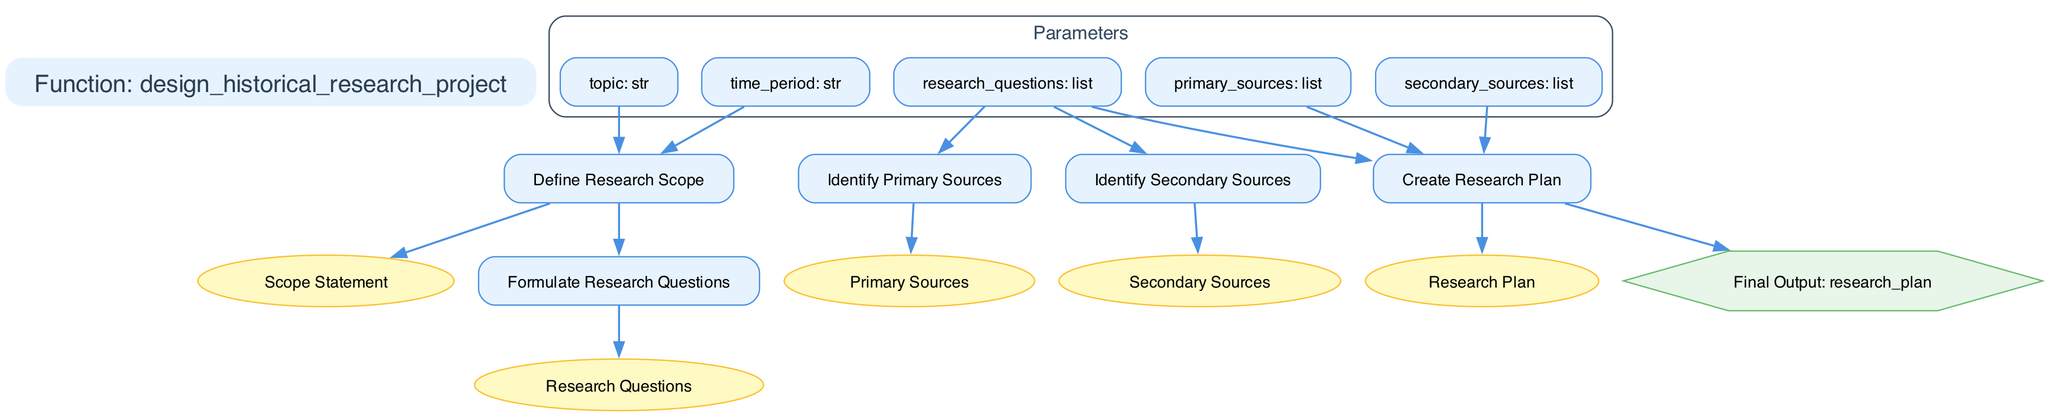What is the name of the function in this diagram? The name of the function is located at the top of the diagram under the title node, which states "Function: design_historical_research_project."
Answer: design_historical_research_project How many steps are in the research design process? By counting the number of nodes that represent the steps of the process, we find there are five steps listed in the diagram: define research scope, formulate research questions, identify primary sources, identify secondary sources, and create research plan.
Answer: 5 What is the output of the last step in the function? The outputs of the last step 'create_research_plan' are detailed in the output node of the diagram, indicating that the final output is the 'research_plan.'
Answer: research_plan Which step has the input "research_questions"? The step "identify_primary_sources" and "identify_secondary_sources" both take "research_questions" as an input, connected by edges leading to these steps in the diagram.
Answer: identify_primary_sources, identify_secondary_sources What connects the "define_research_scope" step to its output? The "define_research_scope" step produces a 'scope_statement' as its output, which is represented by an edge connecting it to the respective output node in the diagram.
Answer: scope_statement Which parameters are connected to the "formulate_research_questions" step? The "formulate_research_questions" step takes one input, which is the 'scope_statement' that comes from the previous step, indicating a sequential flow in the research design process.
Answer: scope_statement What are the inputs required for creating the research plan? The diagram indicates that "research_questions," "primary_sources," and "secondary_sources" are the required inputs for the step "create_research_plan," showing the necessary components to formulate the research plan.
Answer: research_questions, primary_sources, secondary_sources What shape represents the final output of the function? The final output 'research_plan' is depicted as a hexagon shape, which is characteristic of the output node in the diagram design, distinguishing it from other types of nodes.
Answer: hexagon 